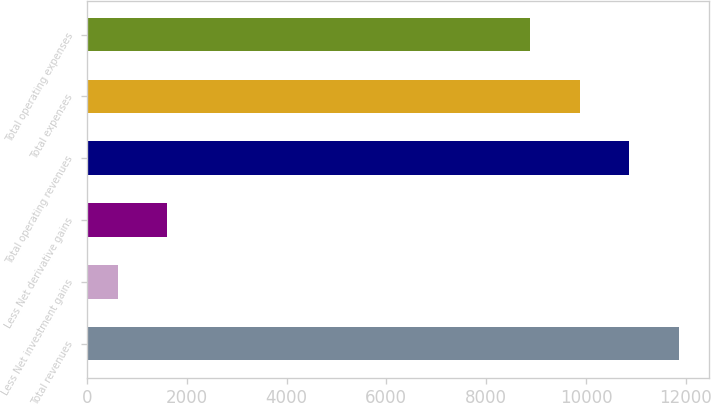Convert chart to OTSL. <chart><loc_0><loc_0><loc_500><loc_500><bar_chart><fcel>Total revenues<fcel>Less Net investment gains<fcel>Less Net derivative gains<fcel>Total operating revenues<fcel>Total expenses<fcel>Total operating expenses<nl><fcel>11861.6<fcel>616<fcel>1608.2<fcel>10869.4<fcel>9877.2<fcel>8885<nl></chart> 